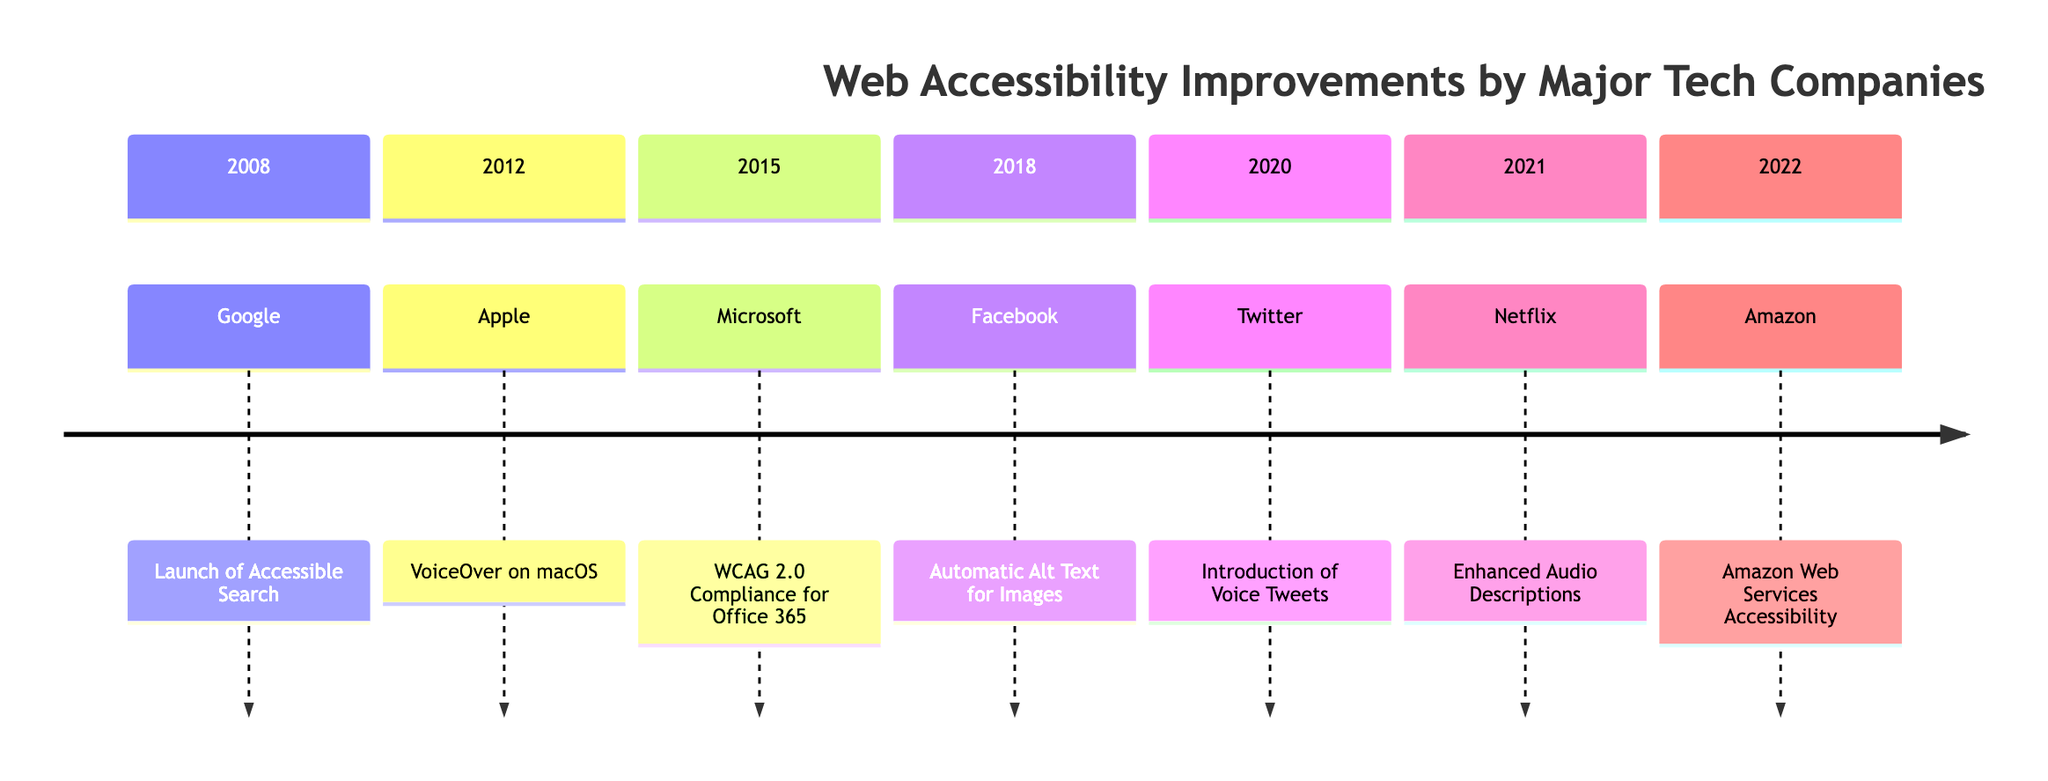What company launched Accessible Search in 2008? The diagram shows that in 2008, Google was the company that launched Accessible Search.
Answer: Google Which year did Apple enhance VoiceOver for macOS? According to the diagram, Apple enhanced VoiceOver in 2012.
Answer: 2012 How many companies introduced significant accessibility features from 2008 to 2022? By counting the events listed in the diagram, there are a total of 7 companies that introduced significant accessibility features from 2008 to 2022.
Answer: 7 What was the event associated with Amazon in 2022? The diagram indicates that the event associated with Amazon in 2022 is "Amazon Web Services Accessibility."
Answer: Amazon Web Services Accessibility Which event follows the Automatic Alt Text for Images on the timeline? The event that follows "Automatic Alt Text for Images" in 2018 is the "Introduction of Voice Tweets" by Twitter in 2020.
Answer: Introduction of Voice Tweets Which company is associated with WCAG 2.0 Compliance in 2015? The diagram shows that Microsoft is the company associated with WCAG 2.0 Compliance in 2015.
Answer: Microsoft What was a notable improvement announced by Netflix in 2021? In 2021, Netflix significantly improved their offerings by enhancing audio descriptions for visually impaired users.
Answer: Enhanced Audio Descriptions What is the chronological order of the events starting from 2008 to 2022? The events can be traced in the timeline as follows: 2008 - Google launches Accessible Search, 2012 - Apple enhances VoiceOver, 2015 - Microsoft achieves WCAG 2.0 Compliance, 2018 - Facebook implements Automatic Alt Text, 2020 - Twitter introduces Voice Tweets, 2021 - Netflix enhances Audio Descriptions, and 2022 - Amazon provides new AWS accessibility features.
Answer: 2008, 2012, 2015, 2018, 2020, 2021, 2022 Which company introduced an AI-powered feature for the visually impaired? The diagram specifies that Facebook introduced the AI-powered automatic alt text system for images, which aids visually impaired users.
Answer: Facebook 